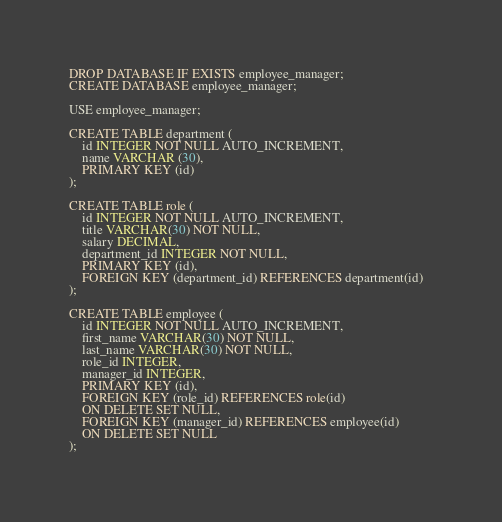<code> <loc_0><loc_0><loc_500><loc_500><_SQL_>DROP DATABASE IF EXISTS employee_manager;
CREATE DATABASE employee_manager;

USE employee_manager;

CREATE TABLE department (
	id INTEGER NOT NULL AUTO_INCREMENT,
    name VARCHAR (30),
    PRIMARY KEY (id)
);

CREATE TABLE role (
	id INTEGER NOT NULL AUTO_INCREMENT,
	title VARCHAR(30) NOT NULL,
	salary DECIMAL,
    department_id INTEGER NOT NULL,
    PRIMARY KEY (id),
    FOREIGN KEY (department_id) REFERENCES department(id)   
);

CREATE TABLE employee (
	id INTEGER NOT NULL AUTO_INCREMENT,
    first_name VARCHAR(30) NOT NULL,
    last_name VARCHAR(30) NOT NULL,
    role_id INTEGER,
    manager_id INTEGER,
    PRIMARY KEY (id),
    FOREIGN KEY (role_id) REFERENCES role(id)
    ON DELETE SET NULL,
    FOREIGN KEY (manager_id) REFERENCES employee(id)
    ON DELETE SET NULL
);</code> 